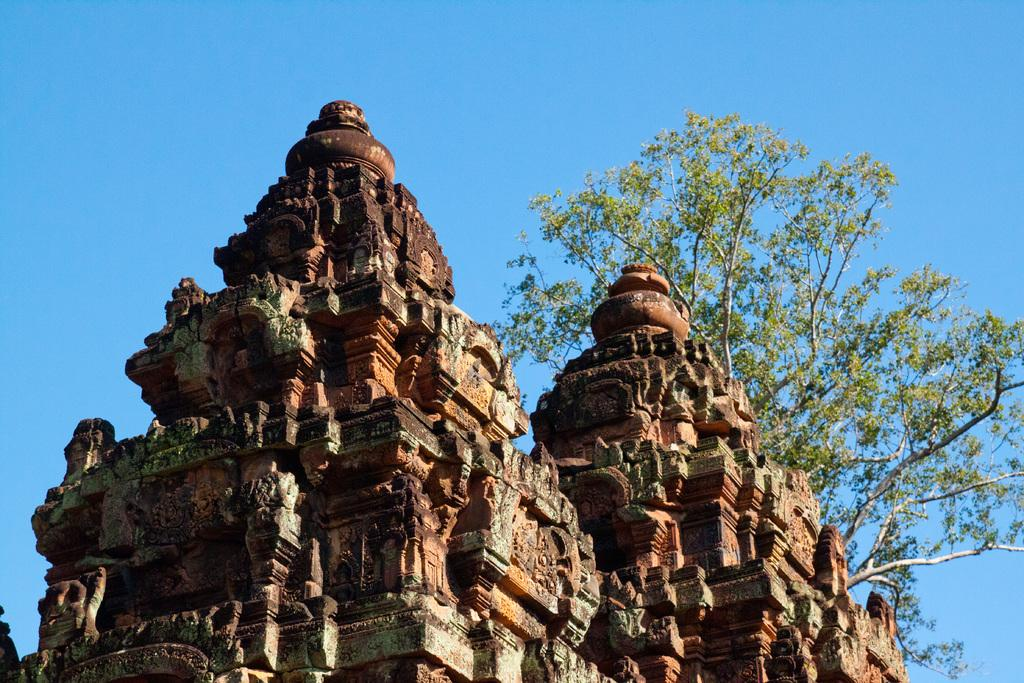How many temples can be seen in the image? There are two temples in the image. What can be found on the temples? The temples have sculptures on them. What is located behind the temple in the image? A: There is a tree behind the temple in the image. What is visible at the top of the image? The sky is visible at the top of the image. What type of brass instrument is being played during the meal in the image? There is no brass instrument or meal present in the image; it features two temples with sculptures and a tree in the background. 